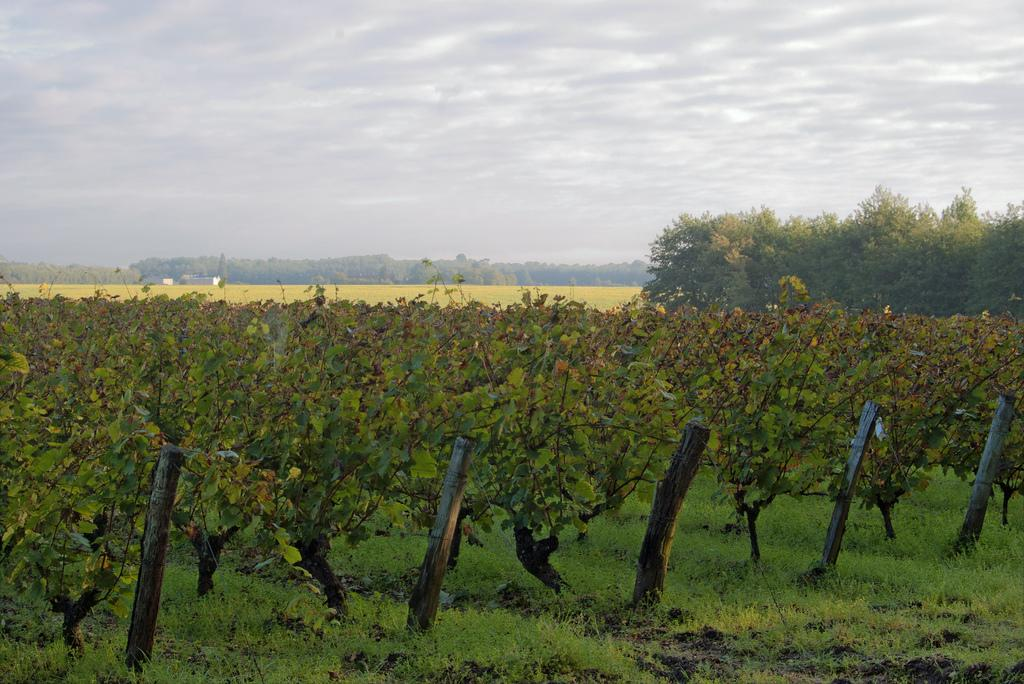What type of vegetation can be seen in the image? There are plants, grass, and trees visible in the image. What material are the poles made of in the image? The wooden poles are present in the image. What is visible in the background of the image? The sky is visible in the background of the image. Can you see any volleyball games being played in the image? There is no volleyball game or any reference to volleyball in the image. How many boats are visible in the image? There are no boats present in the image. 